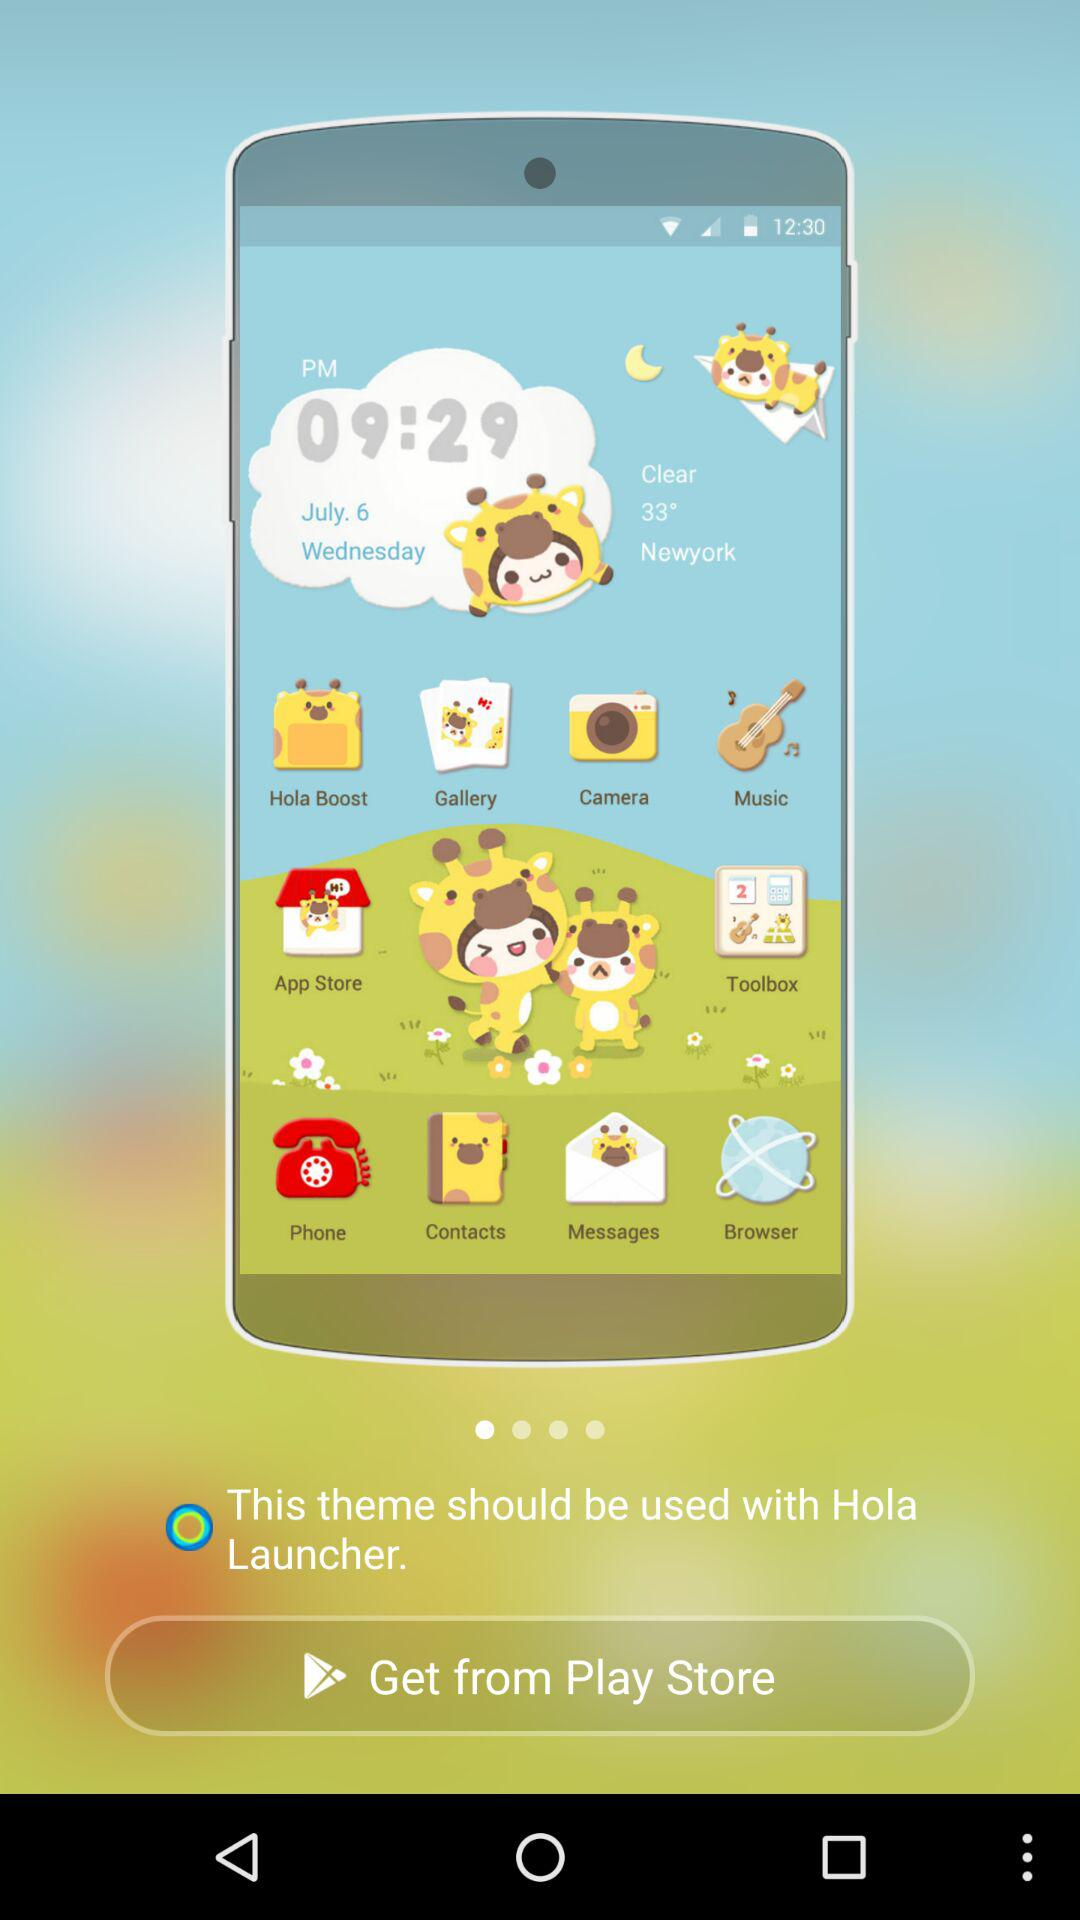Where can the themes be obtained?
When the provided information is insufficient, respond with <no answer>. <no answer> 